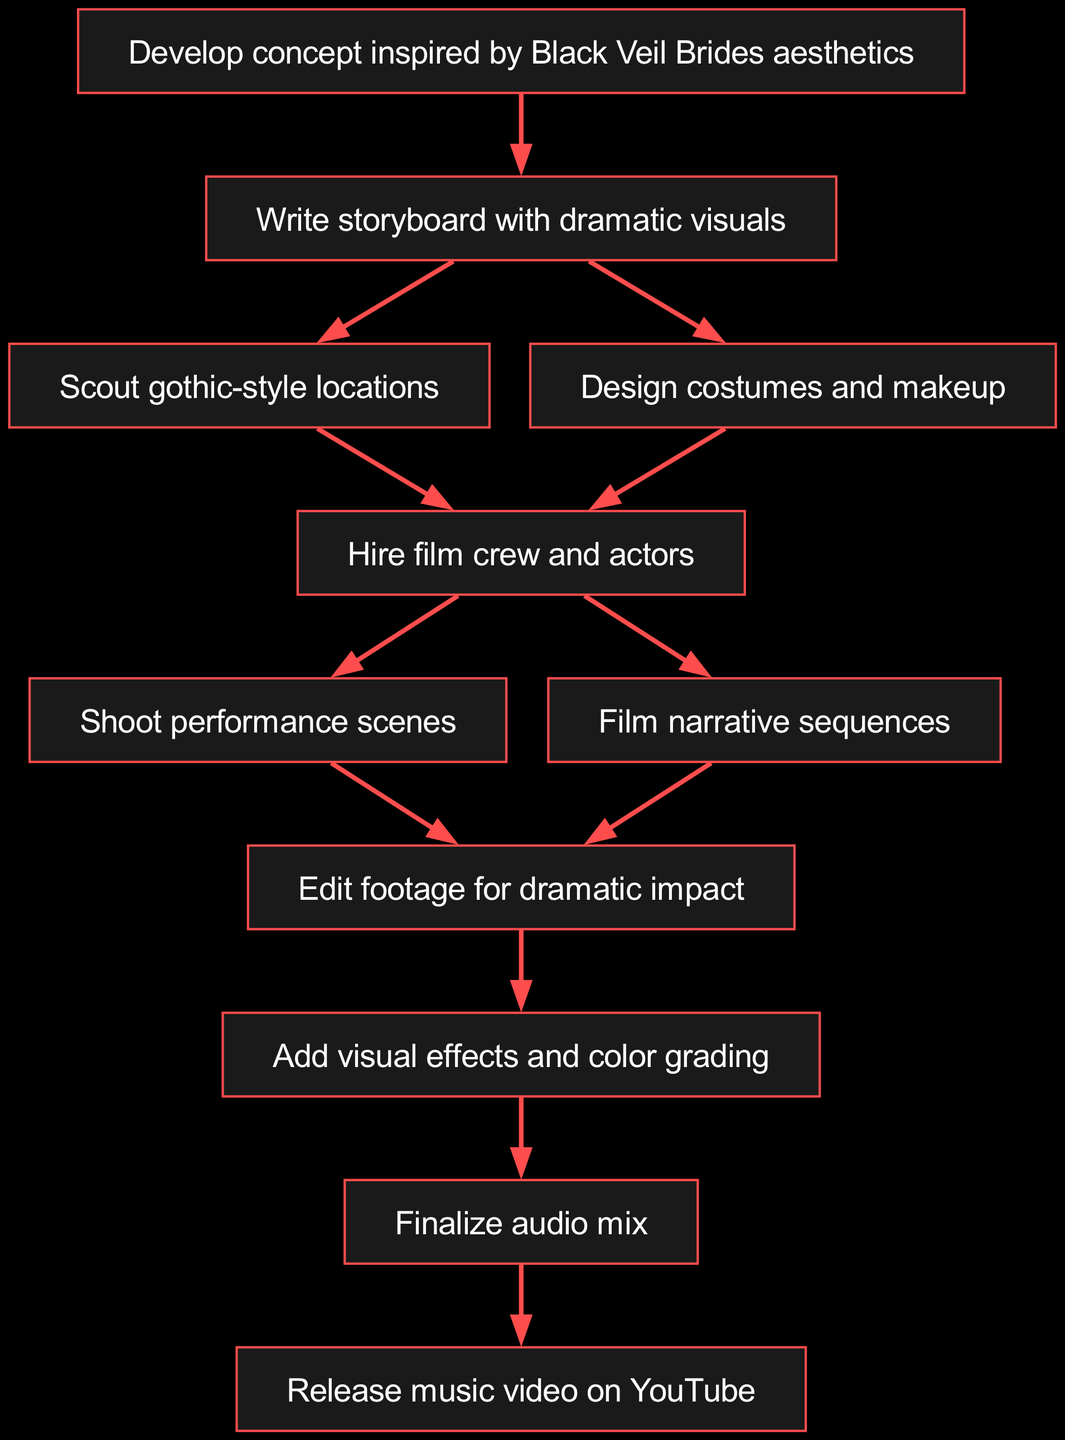What is the first step in creating a music video? The diagram starts with the first node labeled "Develop concept inspired by Black Veil Brides aesthetics," indicating that this is the initial step in the process.
Answer: Develop concept inspired by Black Veil Brides aesthetics How many total nodes are present in this flow chart? By counting each unique node listed in the "nodes" section of the data, we find there are 11 distinct nodes in total.
Answer: 11 Which two activities follow after writing the storyboard? According to the diagram, after the "Write storyboard with dramatic visuals," the next activities are "Scout gothic-style locations" and "Design costumes and makeup," both branching from the storyboard step.
Answer: Scout gothic-style locations and Design costumes and makeup What is the last activity before the music video is released on YouTube? The diagram shows the node "Finalize audio mix" as the last step leading into the release of the music video, which is then directed to the final node.
Answer: Finalize audio mix Which steps occur after hiring the film crew and actors? Following the "Hire film crew and actors" step, the next steps are "Shoot performance scenes" and "Film narrative sequences," indicating the next phases in the production of the music video.
Answer: Shoot performance scenes and Film narrative sequences How many edges connect the "Edit footage for dramatic impact" node? The analysis of the diagram shows there are three edges connecting to the "Edit footage for dramatic impact" node from both "Shoot performance scenes" and "Film narrative sequences," leading to the next step.
Answer: 3 What node is directly linked to adding visual effects? The diagram indicates that "Add visual effects and color grading" directly follows "Edit footage for dramatic impact," which establishes a direct link between these two stages of the music video production process.
Answer: Edit footage for dramatic impact Which node comes before designing costumes and makeup? In the flow, "Write storyboard with dramatic visuals" is the preceding step before moving on to the "Design costumes and makeup" phase, indicating a sequential order in the planning process.
Answer: Write storyboard with dramatic visuals What is the central theme of the concept development for this music video? The first node specifies that the concept development is inspired by the aesthetics of Black Veil Brides, revealing the artistic influence driving the overall production process.
Answer: Black Veil Brides aesthetics 